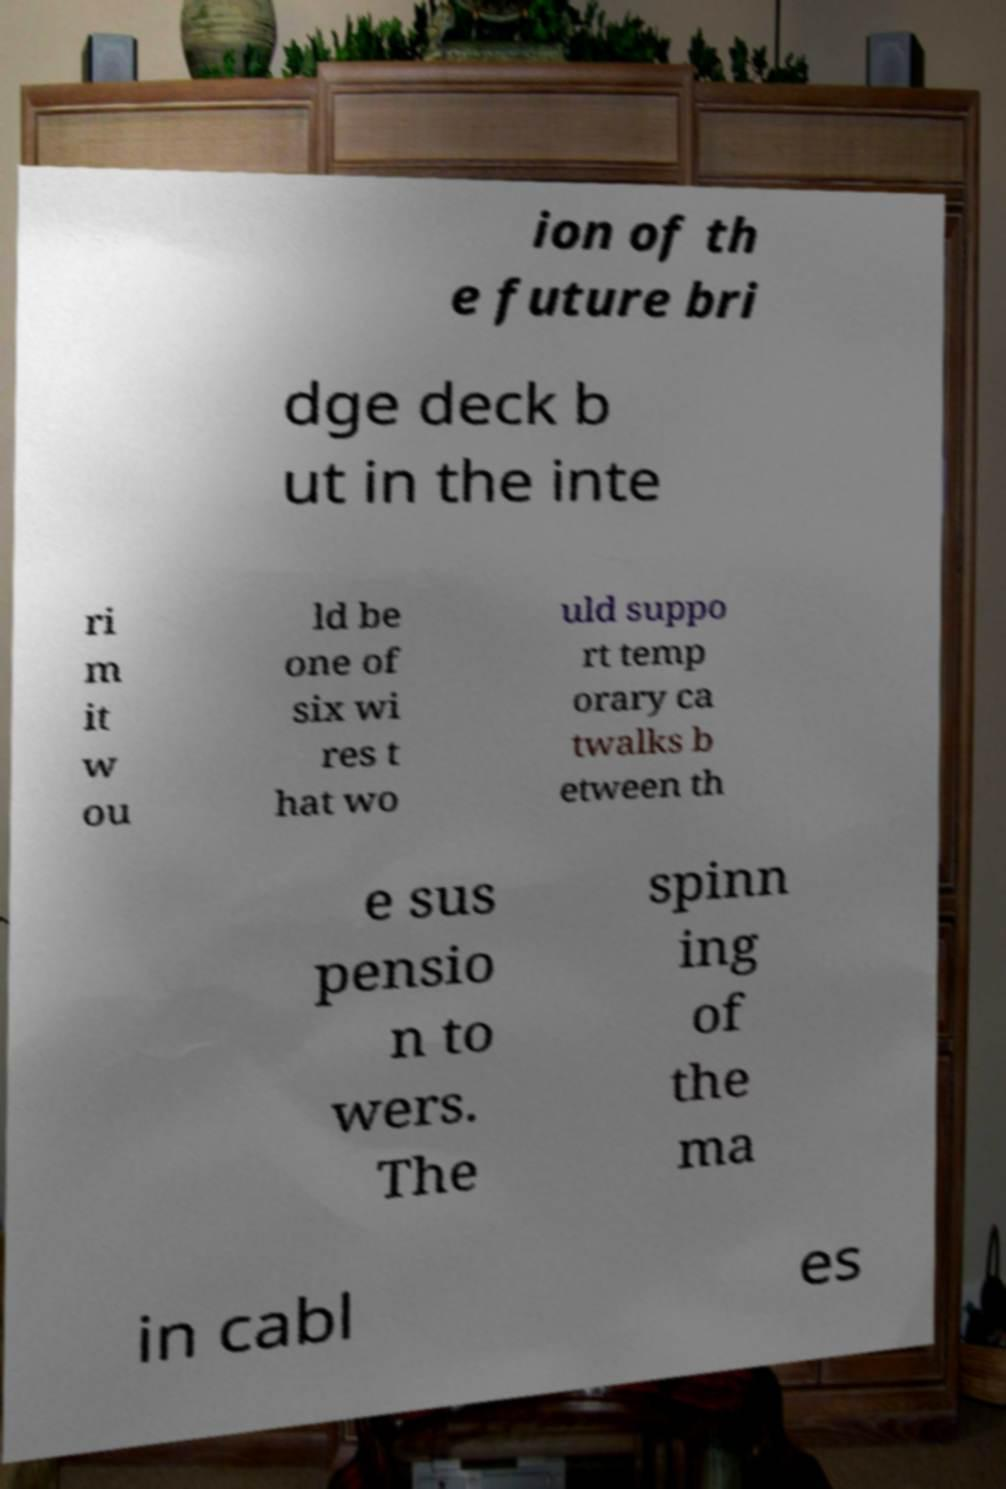For documentation purposes, I need the text within this image transcribed. Could you provide that? ion of th e future bri dge deck b ut in the inte ri m it w ou ld be one of six wi res t hat wo uld suppo rt temp orary ca twalks b etween th e sus pensio n to wers. The spinn ing of the ma in cabl es 